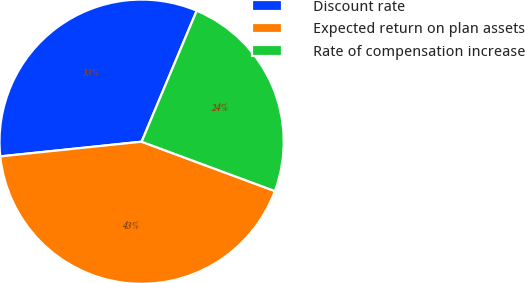Convert chart to OTSL. <chart><loc_0><loc_0><loc_500><loc_500><pie_chart><fcel>Discount rate<fcel>Expected return on plan assets<fcel>Rate of compensation increase<nl><fcel>32.99%<fcel>42.71%<fcel>24.31%<nl></chart> 